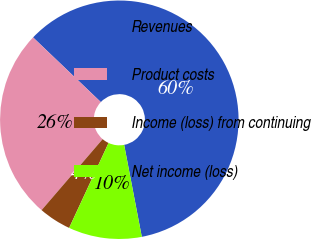<chart> <loc_0><loc_0><loc_500><loc_500><pie_chart><fcel>Revenues<fcel>Product costs<fcel>Income (loss) from continuing<fcel>Net income (loss)<nl><fcel>59.85%<fcel>25.82%<fcel>4.39%<fcel>9.93%<nl></chart> 